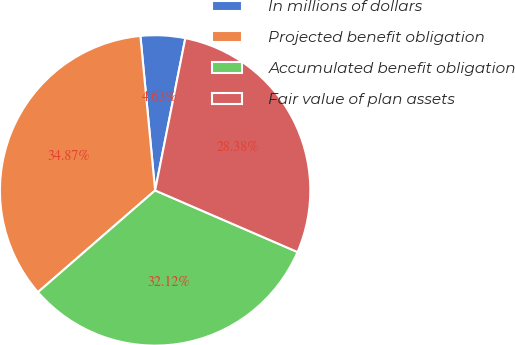<chart> <loc_0><loc_0><loc_500><loc_500><pie_chart><fcel>In millions of dollars<fcel>Projected benefit obligation<fcel>Accumulated benefit obligation<fcel>Fair value of plan assets<nl><fcel>4.63%<fcel>34.87%<fcel>32.12%<fcel>28.38%<nl></chart> 